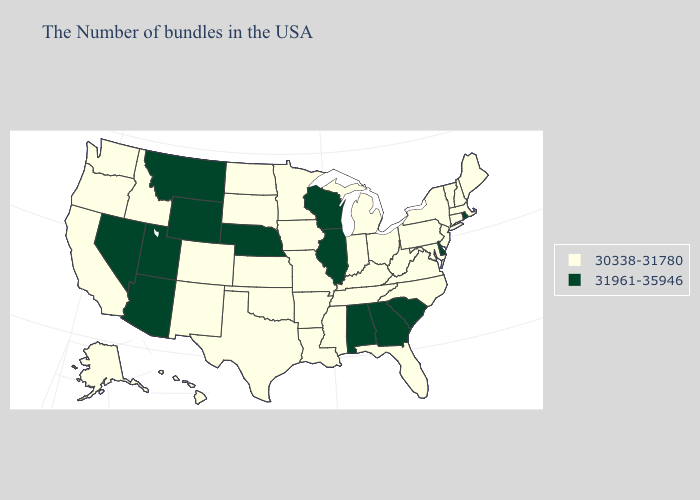What is the lowest value in the USA?
Give a very brief answer. 30338-31780. Does Wisconsin have the lowest value in the MidWest?
Answer briefly. No. Name the states that have a value in the range 31961-35946?
Be succinct. Rhode Island, Delaware, South Carolina, Georgia, Alabama, Wisconsin, Illinois, Nebraska, Wyoming, Utah, Montana, Arizona, Nevada. Among the states that border Oregon , does California have the highest value?
Quick response, please. No. Among the states that border South Carolina , does North Carolina have the lowest value?
Give a very brief answer. Yes. What is the value of Kentucky?
Give a very brief answer. 30338-31780. What is the value of North Dakota?
Concise answer only. 30338-31780. What is the lowest value in states that border Minnesota?
Write a very short answer. 30338-31780. Name the states that have a value in the range 31961-35946?
Answer briefly. Rhode Island, Delaware, South Carolina, Georgia, Alabama, Wisconsin, Illinois, Nebraska, Wyoming, Utah, Montana, Arizona, Nevada. Name the states that have a value in the range 31961-35946?
Keep it brief. Rhode Island, Delaware, South Carolina, Georgia, Alabama, Wisconsin, Illinois, Nebraska, Wyoming, Utah, Montana, Arizona, Nevada. Name the states that have a value in the range 30338-31780?
Be succinct. Maine, Massachusetts, New Hampshire, Vermont, Connecticut, New York, New Jersey, Maryland, Pennsylvania, Virginia, North Carolina, West Virginia, Ohio, Florida, Michigan, Kentucky, Indiana, Tennessee, Mississippi, Louisiana, Missouri, Arkansas, Minnesota, Iowa, Kansas, Oklahoma, Texas, South Dakota, North Dakota, Colorado, New Mexico, Idaho, California, Washington, Oregon, Alaska, Hawaii. How many symbols are there in the legend?
Short answer required. 2. Name the states that have a value in the range 31961-35946?
Write a very short answer. Rhode Island, Delaware, South Carolina, Georgia, Alabama, Wisconsin, Illinois, Nebraska, Wyoming, Utah, Montana, Arizona, Nevada. What is the lowest value in the South?
Answer briefly. 30338-31780. 